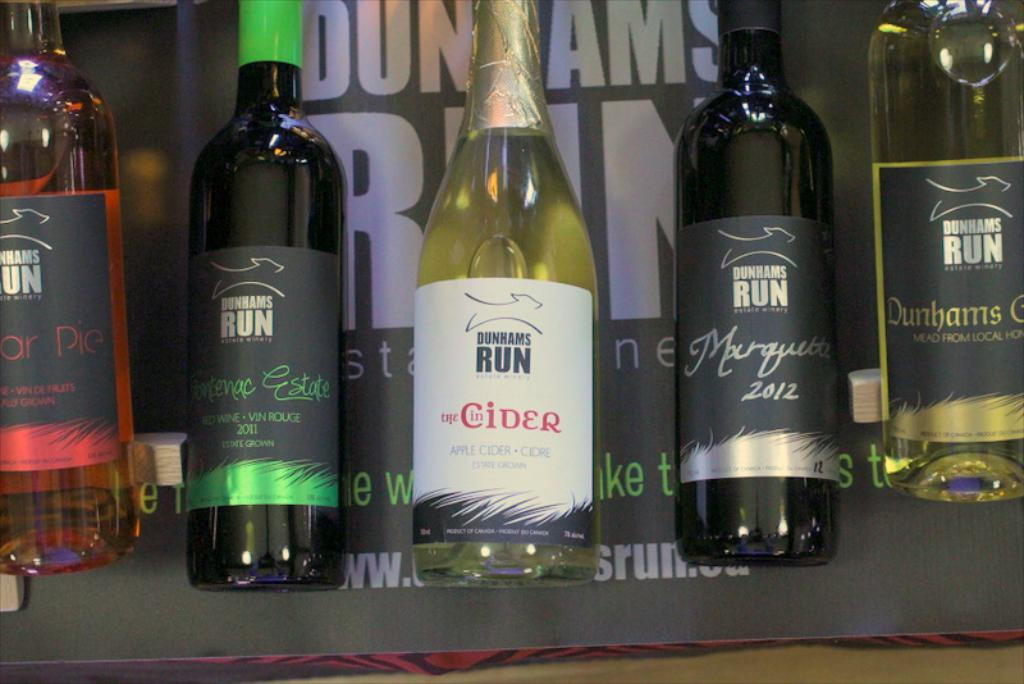Can you tell me more about the types of wine and their flavor profiles featured in the image? Certainly! The image includes a bottle of Frontenac Estate 2011, a red wine likely rich in tannins with a robust flavor profile, and a bottle of Marquette 2012, known for its complex and spicy notes. Both wines are known for their full-bodied characteristics and are excellent examples of fine Canadian viticulture. 